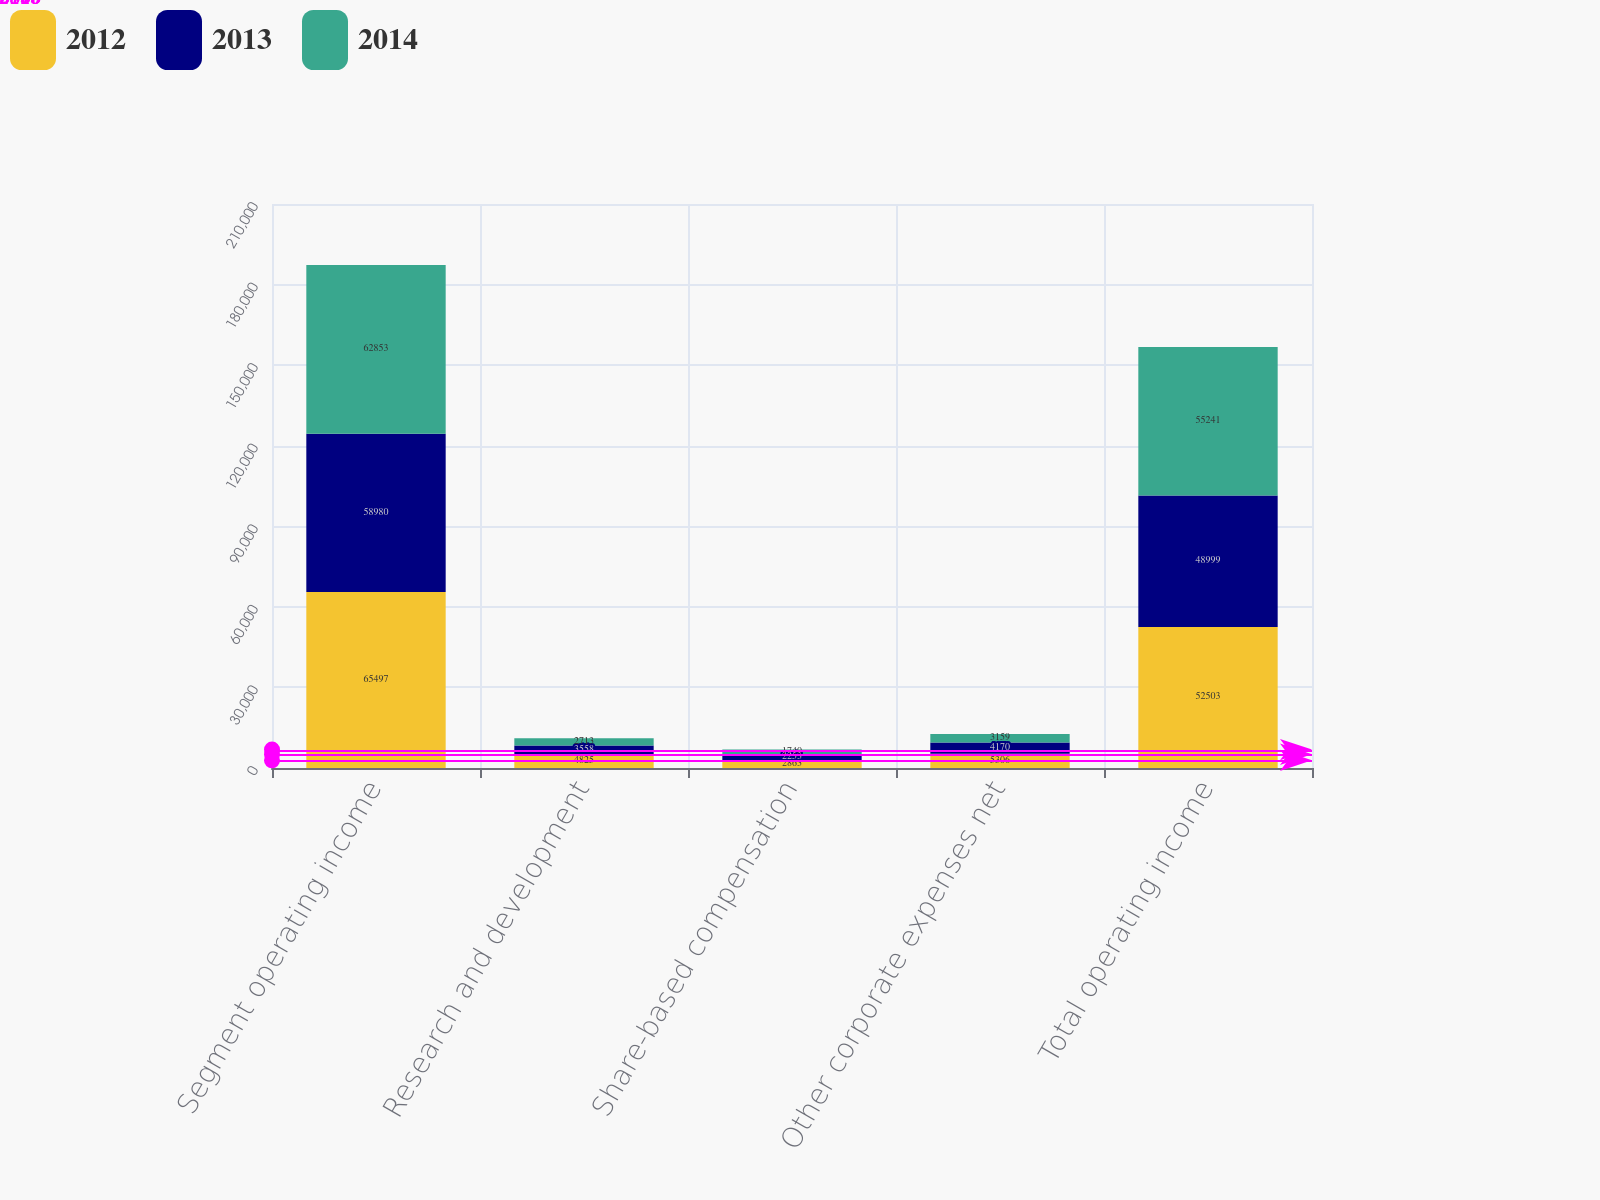Convert chart to OTSL. <chart><loc_0><loc_0><loc_500><loc_500><stacked_bar_chart><ecel><fcel>Segment operating income<fcel>Research and development<fcel>Share-based compensation<fcel>Other corporate expenses net<fcel>Total operating income<nl><fcel>2012<fcel>65497<fcel>4825<fcel>2863<fcel>5306<fcel>52503<nl><fcel>2013<fcel>58980<fcel>3558<fcel>2253<fcel>4170<fcel>48999<nl><fcel>2014<fcel>62853<fcel>2713<fcel>1740<fcel>3159<fcel>55241<nl></chart> 